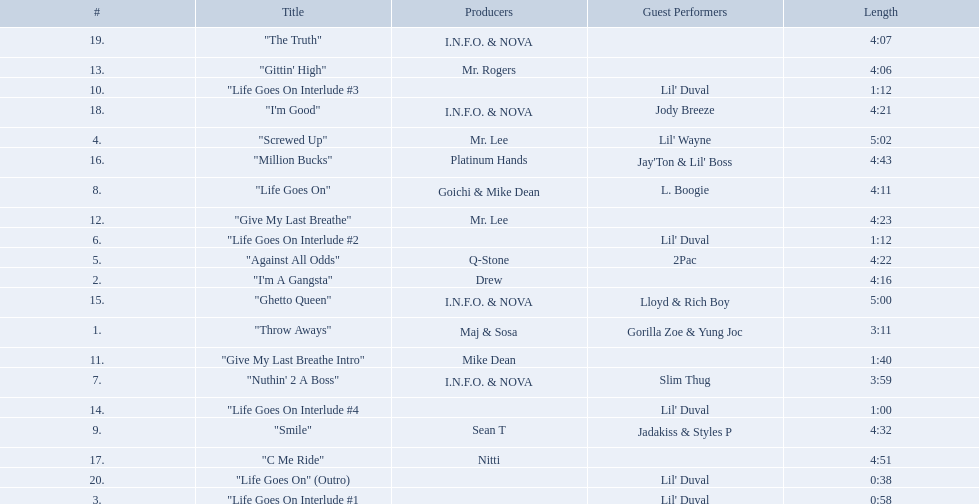What tracks appear on the album life goes on (trae album)? "Throw Aways", "I'm A Gangsta", "Life Goes On Interlude #1, "Screwed Up", "Against All Odds", "Life Goes On Interlude #2, "Nuthin' 2 A Boss", "Life Goes On", "Smile", "Life Goes On Interlude #3, "Give My Last Breathe Intro", "Give My Last Breathe", "Gittin' High", "Life Goes On Interlude #4, "Ghetto Queen", "Million Bucks", "C Me Ride", "I'm Good", "The Truth", "Life Goes On" (Outro). Which of these songs are at least 5 minutes long? "Screwed Up", "Ghetto Queen". Of these two songs over 5 minutes long, which is longer? "Screwed Up". How long is this track? 5:02. 